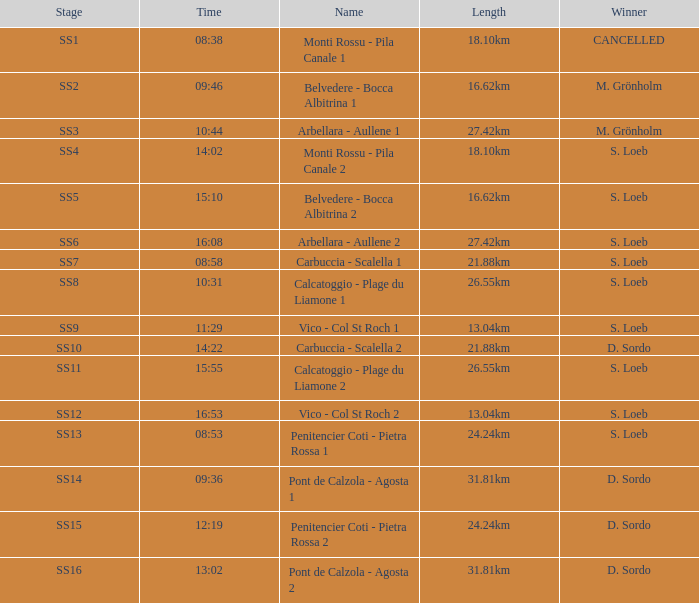What is the Name of the stage with a Length of 16.62km and Time of 15:10? Belvedere - Bocca Albitrina 2. Would you be able to parse every entry in this table? {'header': ['Stage', 'Time', 'Name', 'Length', 'Winner'], 'rows': [['SS1', '08:38', 'Monti Rossu - Pila Canale 1', '18.10km', 'CANCELLED'], ['SS2', '09:46', 'Belvedere - Bocca Albitrina 1', '16.62km', 'M. Grönholm'], ['SS3', '10:44', 'Arbellara - Aullene 1', '27.42km', 'M. Grönholm'], ['SS4', '14:02', 'Monti Rossu - Pila Canale 2', '18.10km', 'S. Loeb'], ['SS5', '15:10', 'Belvedere - Bocca Albitrina 2', '16.62km', 'S. Loeb'], ['SS6', '16:08', 'Arbellara - Aullene 2', '27.42km', 'S. Loeb'], ['SS7', '08:58', 'Carbuccia - Scalella 1', '21.88km', 'S. Loeb'], ['SS8', '10:31', 'Calcatoggio - Plage du Liamone 1', '26.55km', 'S. Loeb'], ['SS9', '11:29', 'Vico - Col St Roch 1', '13.04km', 'S. Loeb'], ['SS10', '14:22', 'Carbuccia - Scalella 2', '21.88km', 'D. Sordo'], ['SS11', '15:55', 'Calcatoggio - Plage du Liamone 2', '26.55km', 'S. Loeb'], ['SS12', '16:53', 'Vico - Col St Roch 2', '13.04km', 'S. Loeb'], ['SS13', '08:53', 'Penitencier Coti - Pietra Rossa 1', '24.24km', 'S. Loeb'], ['SS14', '09:36', 'Pont de Calzola - Agosta 1', '31.81km', 'D. Sordo'], ['SS15', '12:19', 'Penitencier Coti - Pietra Rossa 2', '24.24km', 'D. Sordo'], ['SS16', '13:02', 'Pont de Calzola - Agosta 2', '31.81km', 'D. Sordo']]} 